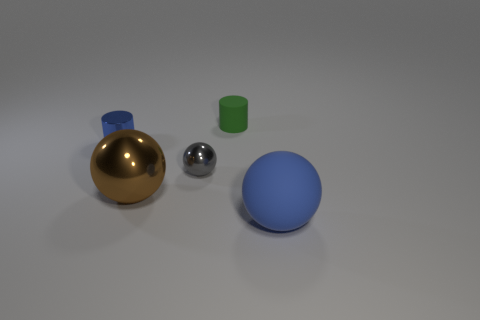Add 5 shiny spheres. How many objects exist? 10 Subtract all balls. How many objects are left? 2 Add 3 small metallic things. How many small metallic things exist? 5 Subtract 0 cyan cylinders. How many objects are left? 5 Subtract all big blue objects. Subtract all cylinders. How many objects are left? 2 Add 5 small blue objects. How many small blue objects are left? 6 